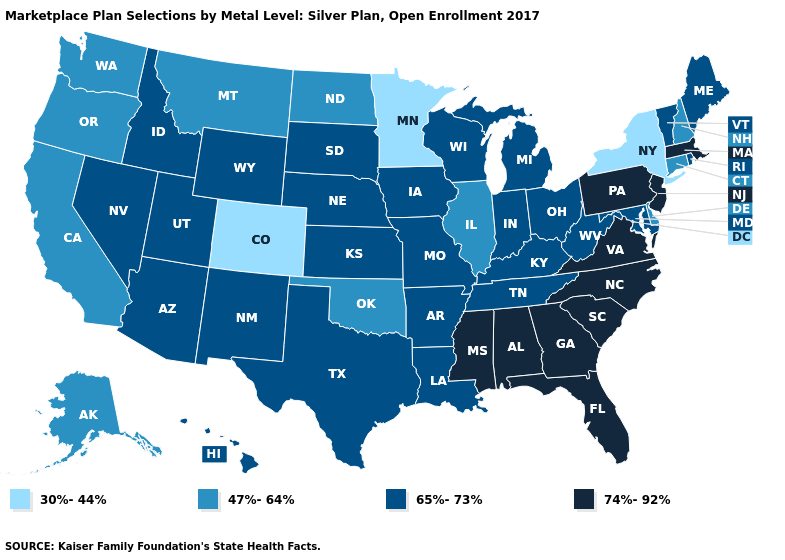How many symbols are there in the legend?
Be succinct. 4. What is the value of Delaware?
Be succinct. 47%-64%. Name the states that have a value in the range 74%-92%?
Keep it brief. Alabama, Florida, Georgia, Massachusetts, Mississippi, New Jersey, North Carolina, Pennsylvania, South Carolina, Virginia. What is the highest value in states that border Wisconsin?
Quick response, please. 65%-73%. What is the highest value in the West ?
Answer briefly. 65%-73%. Which states have the lowest value in the USA?
Quick response, please. Colorado, Minnesota, New York. Among the states that border Connecticut , which have the lowest value?
Answer briefly. New York. How many symbols are there in the legend?
Be succinct. 4. How many symbols are there in the legend?
Answer briefly. 4. What is the value of Iowa?
Concise answer only. 65%-73%. Among the states that border West Virginia , which have the lowest value?
Short answer required. Kentucky, Maryland, Ohio. Among the states that border Idaho , which have the lowest value?
Keep it brief. Montana, Oregon, Washington. Name the states that have a value in the range 47%-64%?
Concise answer only. Alaska, California, Connecticut, Delaware, Illinois, Montana, New Hampshire, North Dakota, Oklahoma, Oregon, Washington. Does the first symbol in the legend represent the smallest category?
Answer briefly. Yes. Does Missouri have the lowest value in the MidWest?
Concise answer only. No. 